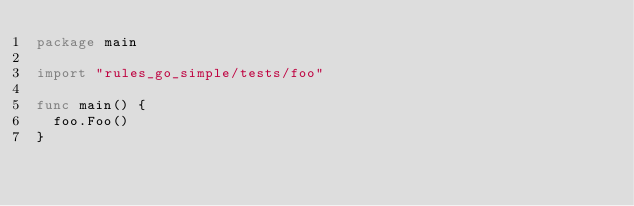<code> <loc_0><loc_0><loc_500><loc_500><_Go_>package main

import "rules_go_simple/tests/foo"

func main() {
	foo.Foo()
}
</code> 